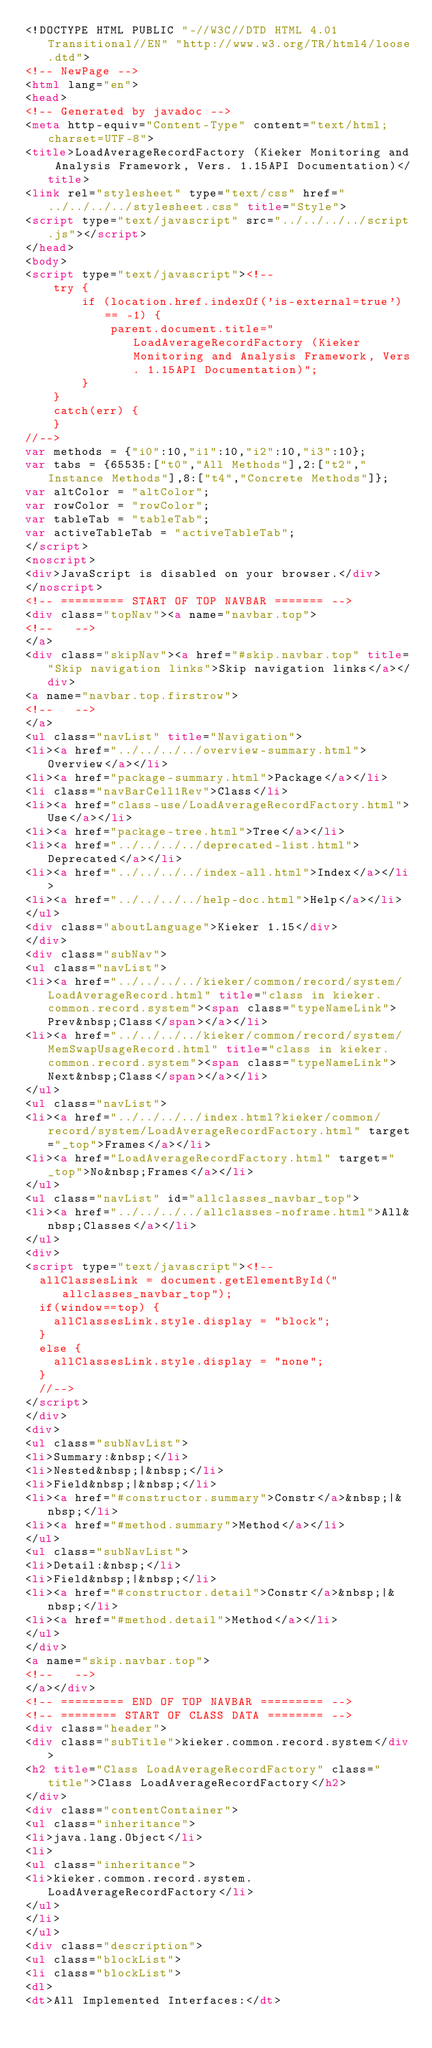Convert code to text. <code><loc_0><loc_0><loc_500><loc_500><_HTML_><!DOCTYPE HTML PUBLIC "-//W3C//DTD HTML 4.01 Transitional//EN" "http://www.w3.org/TR/html4/loose.dtd">
<!-- NewPage -->
<html lang="en">
<head>
<!-- Generated by javadoc -->
<meta http-equiv="Content-Type" content="text/html; charset=UTF-8">
<title>LoadAverageRecordFactory (Kieker Monitoring and Analysis Framework, Vers. 1.15API Documentation)</title>
<link rel="stylesheet" type="text/css" href="../../../../stylesheet.css" title="Style">
<script type="text/javascript" src="../../../../script.js"></script>
</head>
<body>
<script type="text/javascript"><!--
    try {
        if (location.href.indexOf('is-external=true') == -1) {
            parent.document.title="LoadAverageRecordFactory (Kieker Monitoring and Analysis Framework, Vers. 1.15API Documentation)";
        }
    }
    catch(err) {
    }
//-->
var methods = {"i0":10,"i1":10,"i2":10,"i3":10};
var tabs = {65535:["t0","All Methods"],2:["t2","Instance Methods"],8:["t4","Concrete Methods"]};
var altColor = "altColor";
var rowColor = "rowColor";
var tableTab = "tableTab";
var activeTableTab = "activeTableTab";
</script>
<noscript>
<div>JavaScript is disabled on your browser.</div>
</noscript>
<!-- ========= START OF TOP NAVBAR ======= -->
<div class="topNav"><a name="navbar.top">
<!--   -->
</a>
<div class="skipNav"><a href="#skip.navbar.top" title="Skip navigation links">Skip navigation links</a></div>
<a name="navbar.top.firstrow">
<!--   -->
</a>
<ul class="navList" title="Navigation">
<li><a href="../../../../overview-summary.html">Overview</a></li>
<li><a href="package-summary.html">Package</a></li>
<li class="navBarCell1Rev">Class</li>
<li><a href="class-use/LoadAverageRecordFactory.html">Use</a></li>
<li><a href="package-tree.html">Tree</a></li>
<li><a href="../../../../deprecated-list.html">Deprecated</a></li>
<li><a href="../../../../index-all.html">Index</a></li>
<li><a href="../../../../help-doc.html">Help</a></li>
</ul>
<div class="aboutLanguage">Kieker 1.15</div>
</div>
<div class="subNav">
<ul class="navList">
<li><a href="../../../../kieker/common/record/system/LoadAverageRecord.html" title="class in kieker.common.record.system"><span class="typeNameLink">Prev&nbsp;Class</span></a></li>
<li><a href="../../../../kieker/common/record/system/MemSwapUsageRecord.html" title="class in kieker.common.record.system"><span class="typeNameLink">Next&nbsp;Class</span></a></li>
</ul>
<ul class="navList">
<li><a href="../../../../index.html?kieker/common/record/system/LoadAverageRecordFactory.html" target="_top">Frames</a></li>
<li><a href="LoadAverageRecordFactory.html" target="_top">No&nbsp;Frames</a></li>
</ul>
<ul class="navList" id="allclasses_navbar_top">
<li><a href="../../../../allclasses-noframe.html">All&nbsp;Classes</a></li>
</ul>
<div>
<script type="text/javascript"><!--
  allClassesLink = document.getElementById("allclasses_navbar_top");
  if(window==top) {
    allClassesLink.style.display = "block";
  }
  else {
    allClassesLink.style.display = "none";
  }
  //-->
</script>
</div>
<div>
<ul class="subNavList">
<li>Summary:&nbsp;</li>
<li>Nested&nbsp;|&nbsp;</li>
<li>Field&nbsp;|&nbsp;</li>
<li><a href="#constructor.summary">Constr</a>&nbsp;|&nbsp;</li>
<li><a href="#method.summary">Method</a></li>
</ul>
<ul class="subNavList">
<li>Detail:&nbsp;</li>
<li>Field&nbsp;|&nbsp;</li>
<li><a href="#constructor.detail">Constr</a>&nbsp;|&nbsp;</li>
<li><a href="#method.detail">Method</a></li>
</ul>
</div>
<a name="skip.navbar.top">
<!--   -->
</a></div>
<!-- ========= END OF TOP NAVBAR ========= -->
<!-- ======== START OF CLASS DATA ======== -->
<div class="header">
<div class="subTitle">kieker.common.record.system</div>
<h2 title="Class LoadAverageRecordFactory" class="title">Class LoadAverageRecordFactory</h2>
</div>
<div class="contentContainer">
<ul class="inheritance">
<li>java.lang.Object</li>
<li>
<ul class="inheritance">
<li>kieker.common.record.system.LoadAverageRecordFactory</li>
</ul>
</li>
</ul>
<div class="description">
<ul class="blockList">
<li class="blockList">
<dl>
<dt>All Implemented Interfaces:</dt></code> 